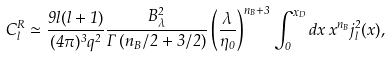<formula> <loc_0><loc_0><loc_500><loc_500>C _ { l } ^ { R } \simeq \frac { 9 l ( l + 1 ) } { ( 4 \pi ) ^ { 3 } q ^ { 2 } } \frac { B ^ { 2 } _ { \lambda } } { \Gamma \left ( n _ { B } / 2 + 3 / 2 \right ) } \left ( \frac { \lambda } { \eta _ { 0 } } \right ) ^ { n _ { B } + 3 } \int _ { 0 } ^ { x _ { D } } d x \, x ^ { n _ { B } } j ^ { 2 } _ { l } ( x ) ,</formula> 